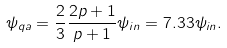<formula> <loc_0><loc_0><loc_500><loc_500>\psi _ { q a } = \frac { 2 } { 3 } \frac { 2 p + 1 } { p + 1 } \psi _ { i n } = 7 . 3 3 \psi _ { i n } .</formula> 